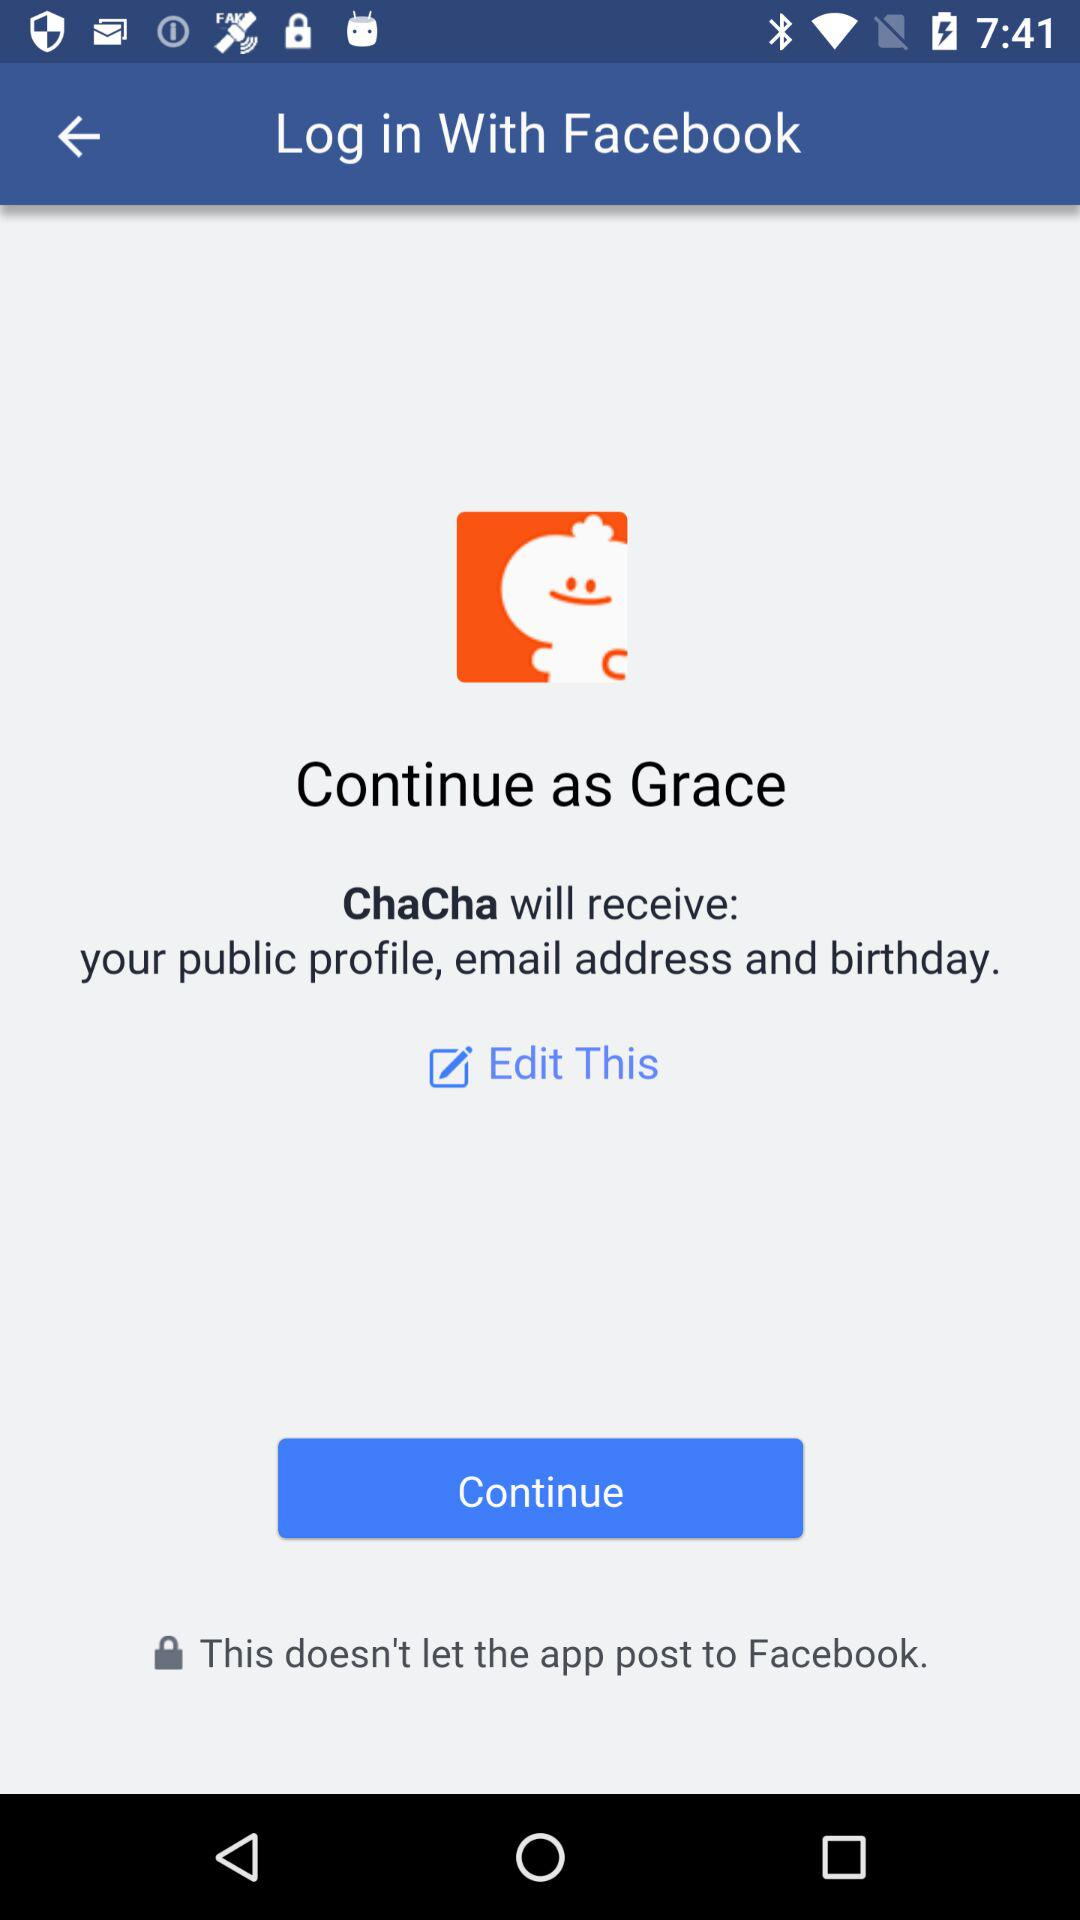What's the user name by which the application can be continued? The user name is Grace. 